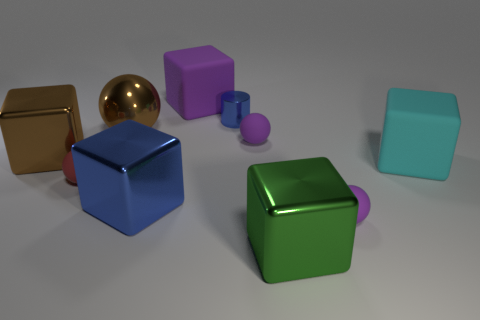Is the number of tiny red matte balls behind the big cyan object less than the number of matte things right of the large purple block?
Offer a terse response. Yes. What is the big brown thing on the left side of the brown shiny sphere made of?
Your response must be concise. Metal. There is a metal cube that is the same color as the small metallic cylinder; what is its size?
Your answer should be compact. Large. Is there a purple object that has the same size as the red thing?
Make the answer very short. Yes. Do the big blue shiny thing and the large rubber thing that is on the right side of the large purple matte thing have the same shape?
Your answer should be very brief. Yes. There is a metallic thing that is on the right side of the tiny blue shiny object; is its size the same as the blue metal thing behind the large cyan object?
Give a very brief answer. No. What number of other things are the same shape as the red matte thing?
Provide a short and direct response. 3. What material is the big block in front of the purple matte sphere in front of the tiny red rubber ball?
Your response must be concise. Metal. What number of rubber objects are balls or big brown spheres?
Provide a succinct answer. 3. There is a tiny purple rubber object that is behind the cyan rubber cube; are there any tiny blue things on the right side of it?
Keep it short and to the point. No. 